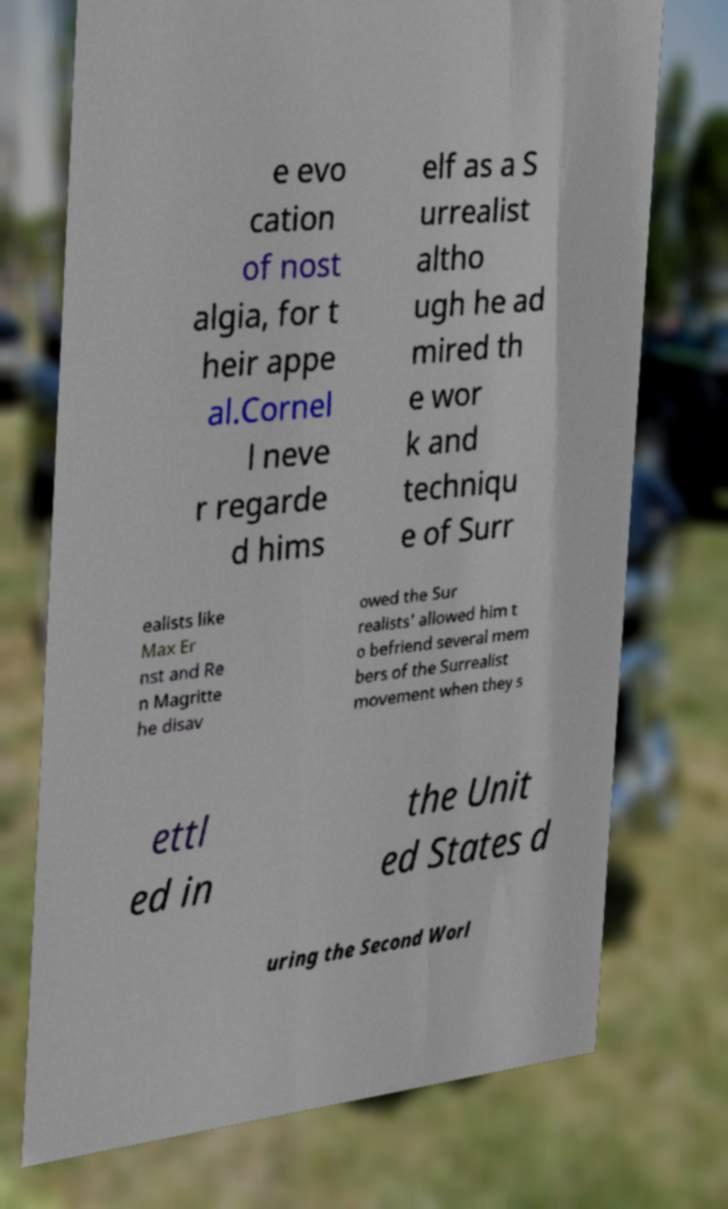Can you read and provide the text displayed in the image?This photo seems to have some interesting text. Can you extract and type it out for me? e evo cation of nost algia, for t heir appe al.Cornel l neve r regarde d hims elf as a S urrealist altho ugh he ad mired th e wor k and techniqu e of Surr ealists like Max Er nst and Re n Magritte he disav owed the Sur realists' allowed him t o befriend several mem bers of the Surrealist movement when they s ettl ed in the Unit ed States d uring the Second Worl 